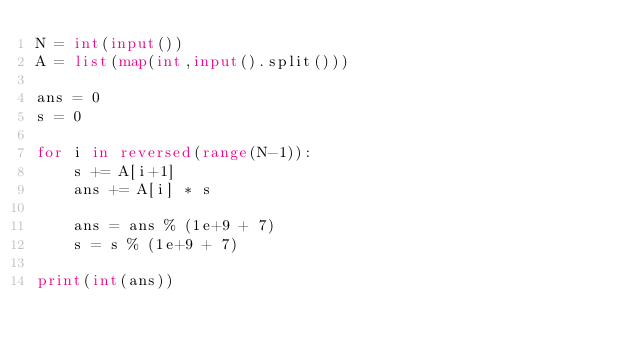Convert code to text. <code><loc_0><loc_0><loc_500><loc_500><_Python_>N = int(input())
A = list(map(int,input().split()))

ans = 0
s = 0

for i in reversed(range(N-1)):
    s += A[i+1]
    ans += A[i] * s

    ans = ans % (1e+9 + 7)
    s = s % (1e+9 + 7)

print(int(ans))</code> 